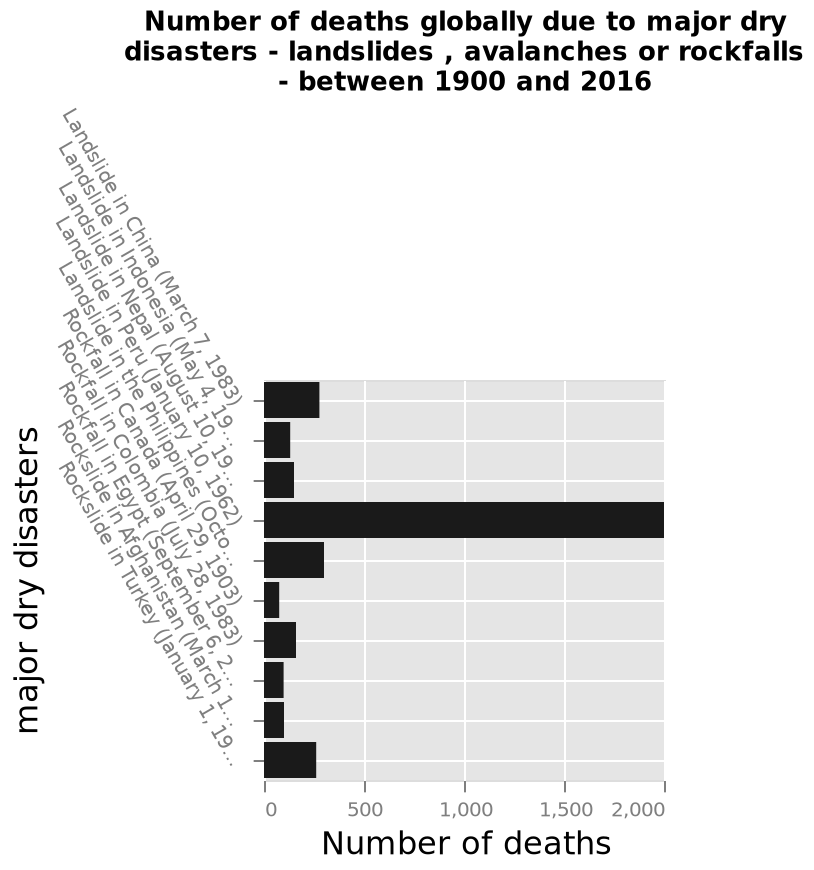<image>
Offer a thorough analysis of the image. Landslide in Peru had the highest death count out of all dry disasters, with 2000 deaths. The disaster with the lowest death count was Rockfall in Canada, with under 500 deaths (around 100). Landslide in Peru had the highest death count of all the landslide disasters, Rockfall in Colombia had the highest death count of all rockfall disasters and Rockslide in Turkey had the highest death count of rockslide disasters. Landslide in Peru was the only disaster to have a death count over 500 people. What does the x-axis measure in the bar plot?  The x-axis measures the number of deaths. Which country had the most significant number of deaths recorded?  Peru What is the main focus of the bar plot? The main focus of the bar plot is to show the number of deaths globally due to major dry disasters. 